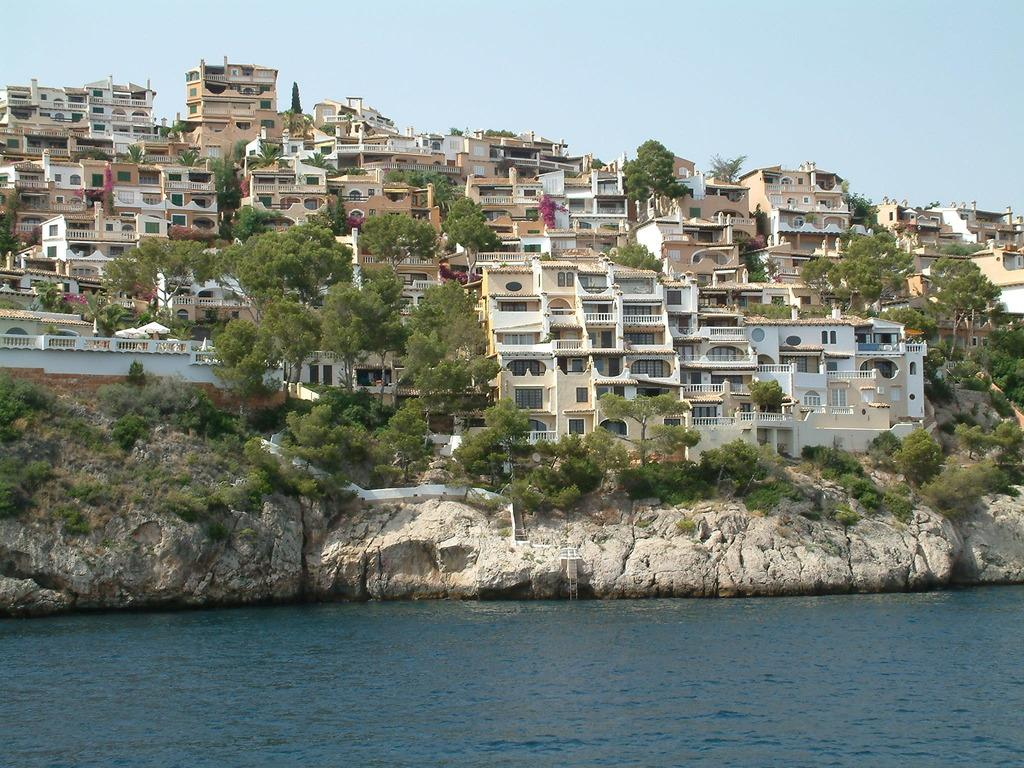What is present at the bottom of the image? There is water at the bottom of the image. What can be seen in the middle of the image? There are many buildings, trees, and rocks in the middle of the image. What is visible at the top of the image? The sky is visible at the top of the image. Can you tell me how many soldiers are in the army depicted in the image? There is no army or soldiers present in the image. Is there anyone swimming in the water at the bottom of the image? There is no one swimming in the water at the bottom of the image. 